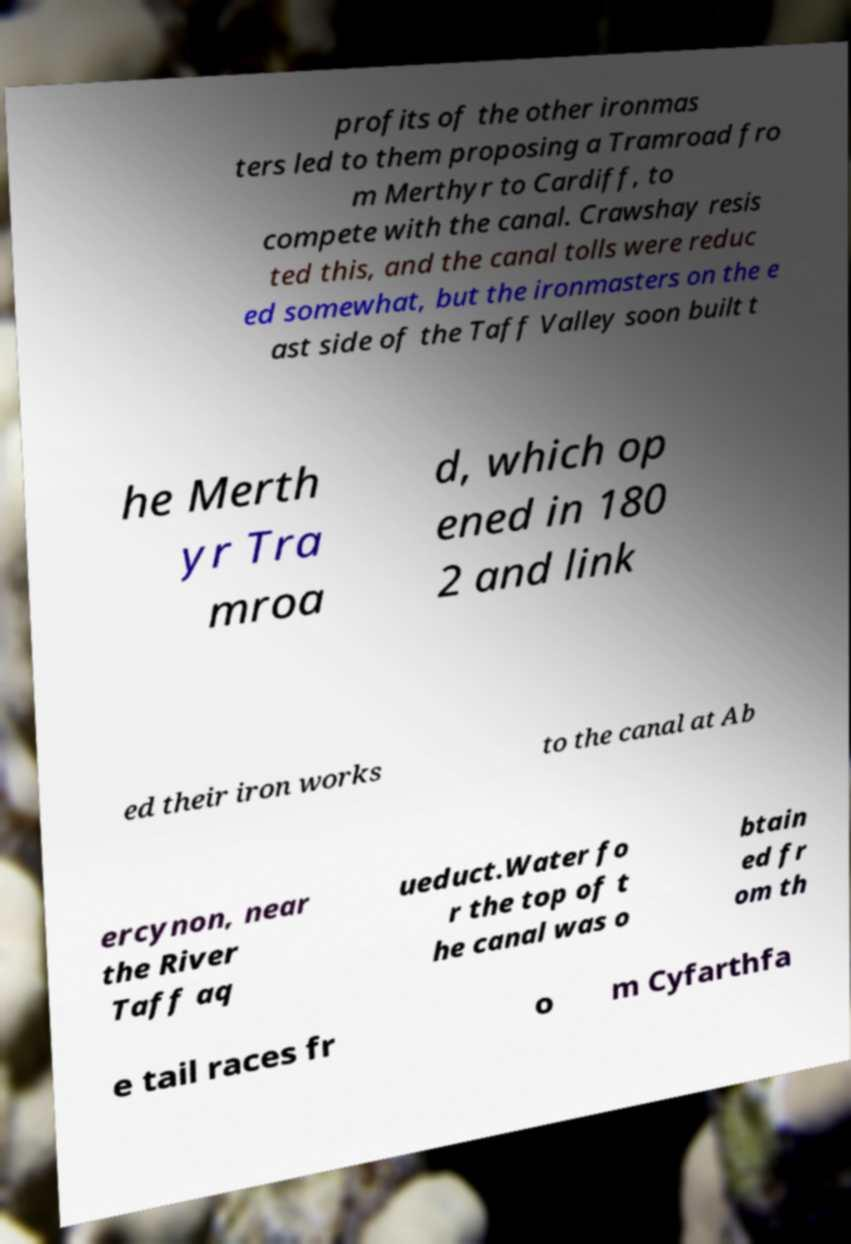Please identify and transcribe the text found in this image. profits of the other ironmas ters led to them proposing a Tramroad fro m Merthyr to Cardiff, to compete with the canal. Crawshay resis ted this, and the canal tolls were reduc ed somewhat, but the ironmasters on the e ast side of the Taff Valley soon built t he Merth yr Tra mroa d, which op ened in 180 2 and link ed their iron works to the canal at Ab ercynon, near the River Taff aq ueduct.Water fo r the top of t he canal was o btain ed fr om th e tail races fr o m Cyfarthfa 